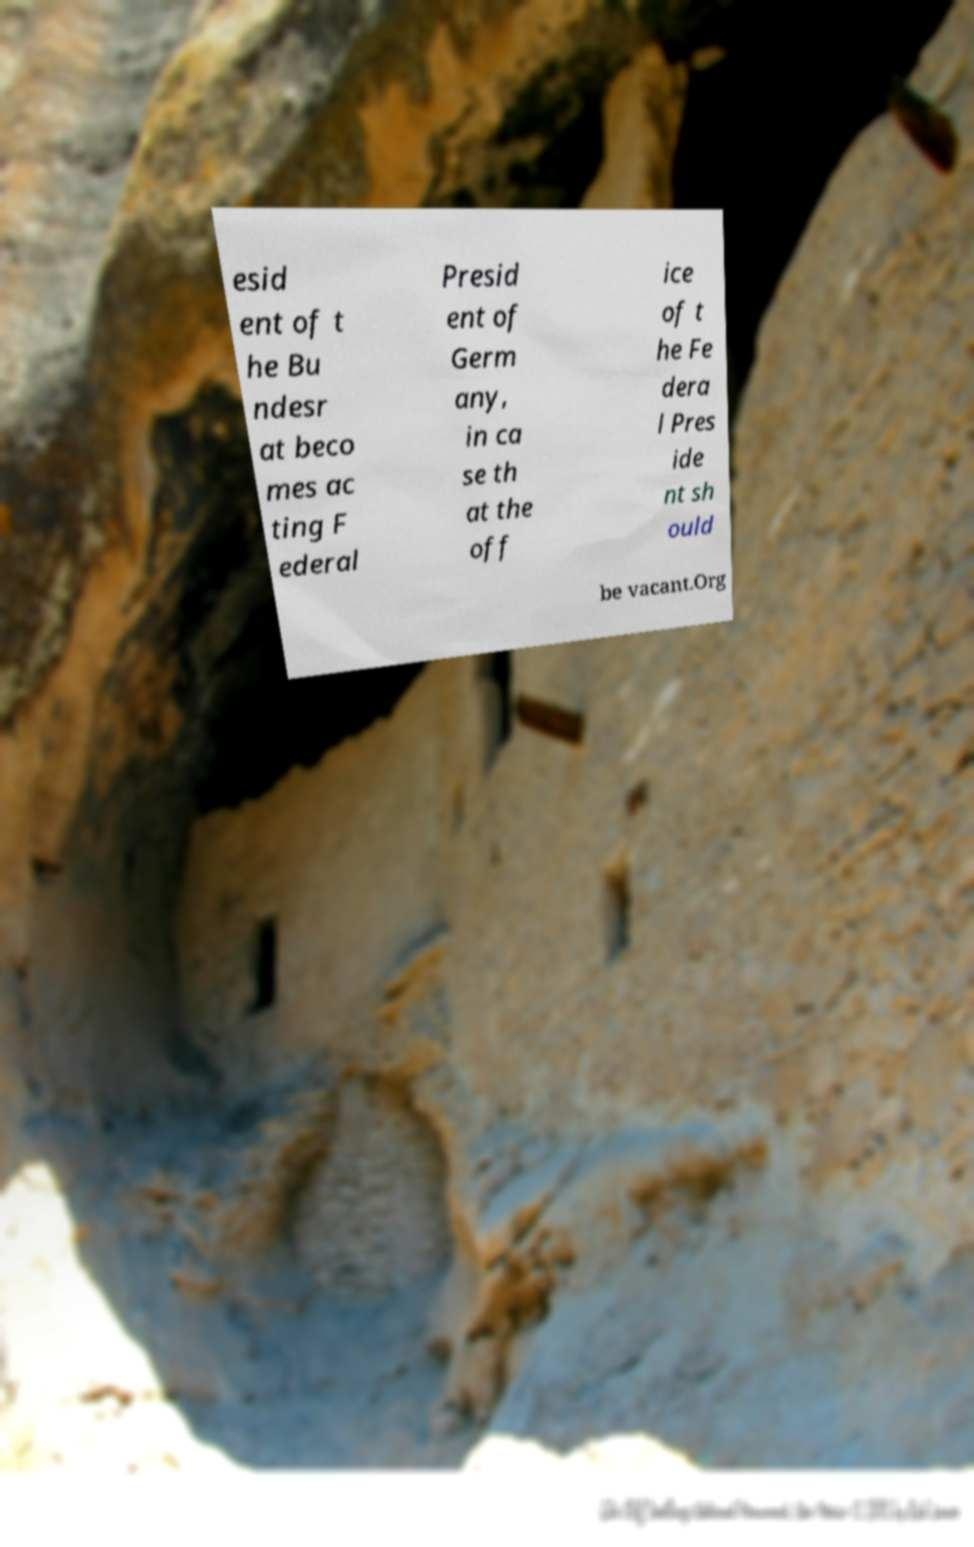There's text embedded in this image that I need extracted. Can you transcribe it verbatim? esid ent of t he Bu ndesr at beco mes ac ting F ederal Presid ent of Germ any, in ca se th at the off ice of t he Fe dera l Pres ide nt sh ould be vacant.Org 